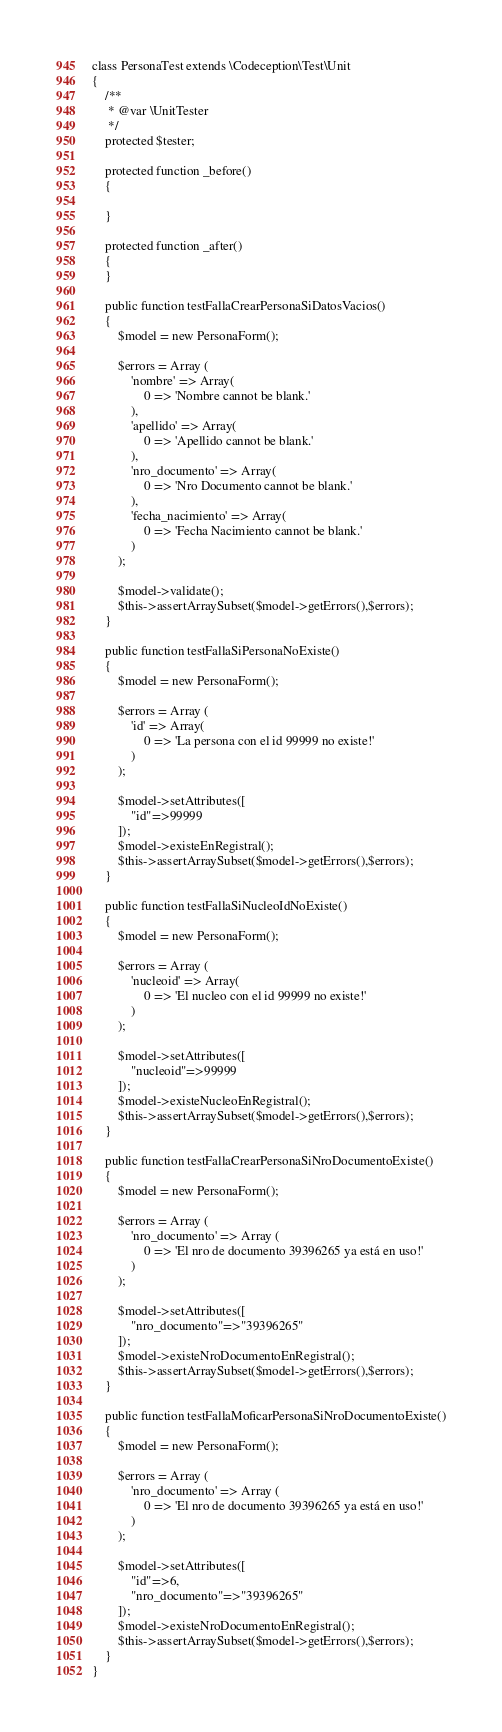Convert code to text. <code><loc_0><loc_0><loc_500><loc_500><_PHP_>class PersonaTest extends \Codeception\Test\Unit
{
    /**
     * @var \UnitTester
     */
    protected $tester;
    
    protected function _before()
    {
        
    }

    protected function _after()
    {
    }

    public function testFallaCrearPersonaSiDatosVacios()
    {        
        $model = new PersonaForm();
        
        $errors = Array (
            'nombre' => Array(
                0 => 'Nombre cannot be blank.'
            ),
            'apellido' => Array(
                0 => 'Apellido cannot be blank.'
            ),
            'nro_documento' => Array(
                0 => 'Nro Documento cannot be blank.'
            ),
            'fecha_nacimiento' => Array(
                0 => 'Fecha Nacimiento cannot be blank.'
            )
        );

        $model->validate();
        $this->assertArraySubset($model->getErrors(),$errors);
    }
    
    public function testFallaSiPersonaNoExiste()
    {        
        $model = new PersonaForm();
        
        $errors = Array (
            'id' => Array(
                0 => 'La persona con el id 99999 no existe!'
            )
        );
        
        $model->setAttributes([
            "id"=>99999
        ]);
        $model->existeEnRegistral();
        $this->assertArraySubset($model->getErrors(),$errors);
    }
    
    public function testFallaSiNucleoIdNoExiste()
    {        
        $model = new PersonaForm();
        
        $errors = Array (
            'nucleoid' => Array(
                0 => 'El nucleo con el id 99999 no existe!'
            )
        );
        
        $model->setAttributes([
            "nucleoid"=>99999
        ]);
        $model->existeNucleoEnRegistral();
        $this->assertArraySubset($model->getErrors(),$errors);
    }
    
    public function testFallaCrearPersonaSiNroDocumentoExiste()
    {        
        $model = new PersonaForm();
        
        $errors = Array (
            'nro_documento' => Array (
                0 => 'El nro de documento 39396265 ya está en uso!'
            )
        );
        
        $model->setAttributes([
            "nro_documento"=>"39396265"
        ]);
        $model->existeNroDocumentoEnRegistral();
        $this->assertArraySubset($model->getErrors(),$errors);
    }
    
    public function testFallaMoficarPersonaSiNroDocumentoExiste()
    {        
        $model = new PersonaForm();
        
        $errors = Array (
            'nro_documento' => Array (
                0 => 'El nro de documento 39396265 ya está en uso!'
            )
        );
        
        $model->setAttributes([
            "id"=>6,
            "nro_documento"=>"39396265"
        ]);
        $model->existeNroDocumentoEnRegistral();
        $this->assertArraySubset($model->getErrors(),$errors);
    }
}</code> 